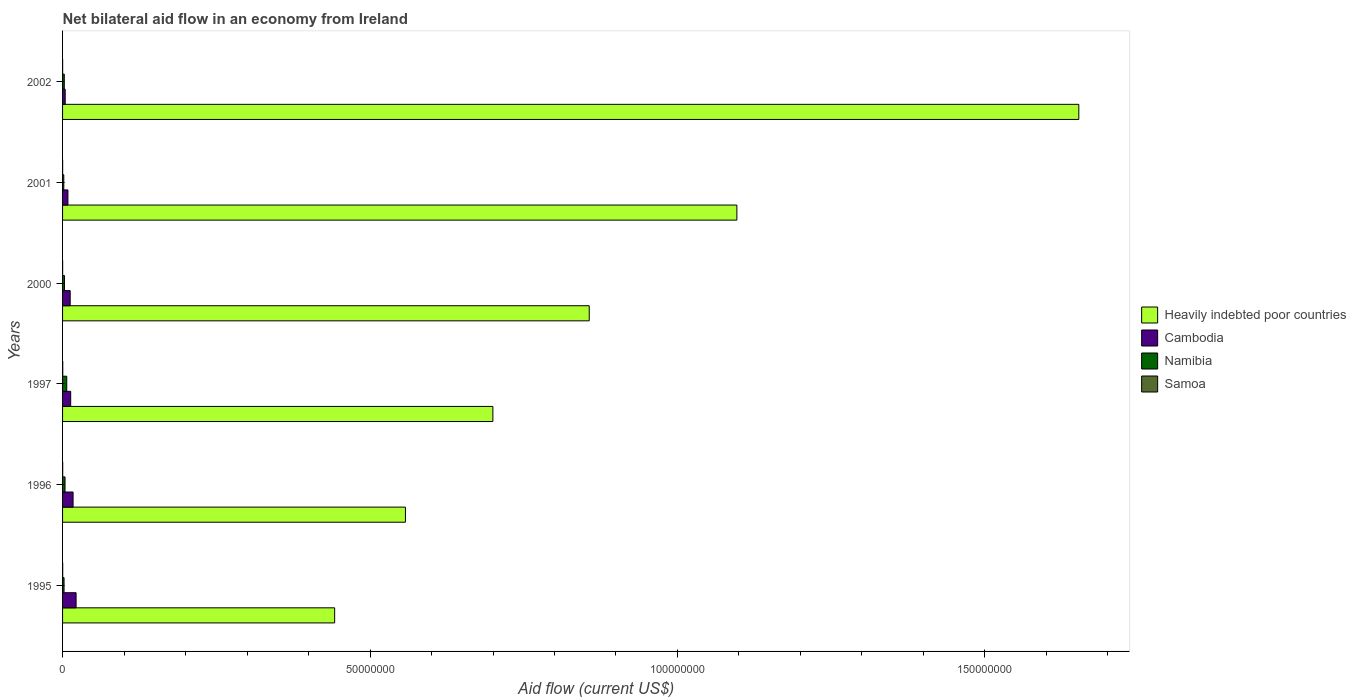Are the number of bars per tick equal to the number of legend labels?
Your answer should be very brief. Yes. How many bars are there on the 4th tick from the bottom?
Make the answer very short. 4. In how many cases, is the number of bars for a given year not equal to the number of legend labels?
Your answer should be compact. 0. What is the net bilateral aid flow in Cambodia in 1997?
Your answer should be compact. 1.32e+06. Across all years, what is the maximum net bilateral aid flow in Samoa?
Offer a terse response. 3.00e+04. Across all years, what is the minimum net bilateral aid flow in Samoa?
Your answer should be compact. 10000. What is the total net bilateral aid flow in Heavily indebted poor countries in the graph?
Provide a short and direct response. 5.31e+08. What is the difference between the net bilateral aid flow in Samoa in 1995 and that in 2000?
Your answer should be compact. 10000. What is the difference between the net bilateral aid flow in Heavily indebted poor countries in 1996 and the net bilateral aid flow in Samoa in 1995?
Provide a succinct answer. 5.57e+07. What is the average net bilateral aid flow in Namibia per year?
Provide a succinct answer. 3.52e+05. In the year 2000, what is the difference between the net bilateral aid flow in Namibia and net bilateral aid flow in Samoa?
Provide a short and direct response. 3.00e+05. In how many years, is the net bilateral aid flow in Samoa greater than 90000000 US$?
Ensure brevity in your answer.  0. What is the ratio of the net bilateral aid flow in Heavily indebted poor countries in 1995 to that in 2002?
Ensure brevity in your answer.  0.27. What is the difference between the highest and the lowest net bilateral aid flow in Heavily indebted poor countries?
Provide a succinct answer. 1.21e+08. In how many years, is the net bilateral aid flow in Cambodia greater than the average net bilateral aid flow in Cambodia taken over all years?
Your response must be concise. 3. Is the sum of the net bilateral aid flow in Namibia in 1995 and 2000 greater than the maximum net bilateral aid flow in Samoa across all years?
Ensure brevity in your answer.  Yes. Is it the case that in every year, the sum of the net bilateral aid flow in Cambodia and net bilateral aid flow in Heavily indebted poor countries is greater than the sum of net bilateral aid flow in Samoa and net bilateral aid flow in Namibia?
Make the answer very short. Yes. What does the 1st bar from the top in 2000 represents?
Your response must be concise. Samoa. What does the 2nd bar from the bottom in 1995 represents?
Give a very brief answer. Cambodia. Is it the case that in every year, the sum of the net bilateral aid flow in Samoa and net bilateral aid flow in Heavily indebted poor countries is greater than the net bilateral aid flow in Namibia?
Keep it short and to the point. Yes. How many years are there in the graph?
Offer a very short reply. 6. What is the difference between two consecutive major ticks on the X-axis?
Your answer should be compact. 5.00e+07. Are the values on the major ticks of X-axis written in scientific E-notation?
Keep it short and to the point. No. Does the graph contain any zero values?
Provide a succinct answer. No. What is the title of the graph?
Provide a succinct answer. Net bilateral aid flow in an economy from Ireland. Does "Ukraine" appear as one of the legend labels in the graph?
Give a very brief answer. No. What is the label or title of the X-axis?
Your answer should be compact. Aid flow (current US$). What is the Aid flow (current US$) of Heavily indebted poor countries in 1995?
Make the answer very short. 4.42e+07. What is the Aid flow (current US$) of Cambodia in 1995?
Keep it short and to the point. 2.20e+06. What is the Aid flow (current US$) of Namibia in 1995?
Make the answer very short. 2.40e+05. What is the Aid flow (current US$) of Samoa in 1995?
Offer a terse response. 2.00e+04. What is the Aid flow (current US$) in Heavily indebted poor countries in 1996?
Offer a terse response. 5.58e+07. What is the Aid flow (current US$) in Cambodia in 1996?
Provide a succinct answer. 1.71e+06. What is the Aid flow (current US$) of Namibia in 1996?
Your response must be concise. 4.00e+05. What is the Aid flow (current US$) in Heavily indebted poor countries in 1997?
Offer a very short reply. 7.00e+07. What is the Aid flow (current US$) of Cambodia in 1997?
Your response must be concise. 1.32e+06. What is the Aid flow (current US$) in Namibia in 1997?
Make the answer very short. 6.80e+05. What is the Aid flow (current US$) in Heavily indebted poor countries in 2000?
Offer a very short reply. 8.56e+07. What is the Aid flow (current US$) in Cambodia in 2000?
Provide a succinct answer. 1.24e+06. What is the Aid flow (current US$) in Namibia in 2000?
Give a very brief answer. 3.10e+05. What is the Aid flow (current US$) of Heavily indebted poor countries in 2001?
Provide a short and direct response. 1.10e+08. What is the Aid flow (current US$) of Cambodia in 2001?
Offer a terse response. 8.70e+05. What is the Aid flow (current US$) of Namibia in 2001?
Offer a terse response. 2.00e+05. What is the Aid flow (current US$) in Samoa in 2001?
Offer a terse response. 10000. What is the Aid flow (current US$) in Heavily indebted poor countries in 2002?
Offer a terse response. 1.65e+08. What is the Aid flow (current US$) in Cambodia in 2002?
Make the answer very short. 4.30e+05. What is the Aid flow (current US$) in Namibia in 2002?
Your answer should be compact. 2.80e+05. What is the Aid flow (current US$) of Samoa in 2002?
Make the answer very short. 10000. Across all years, what is the maximum Aid flow (current US$) of Heavily indebted poor countries?
Your answer should be very brief. 1.65e+08. Across all years, what is the maximum Aid flow (current US$) of Cambodia?
Your answer should be very brief. 2.20e+06. Across all years, what is the maximum Aid flow (current US$) of Namibia?
Provide a short and direct response. 6.80e+05. Across all years, what is the maximum Aid flow (current US$) in Samoa?
Offer a very short reply. 3.00e+04. Across all years, what is the minimum Aid flow (current US$) in Heavily indebted poor countries?
Ensure brevity in your answer.  4.42e+07. What is the total Aid flow (current US$) of Heavily indebted poor countries in the graph?
Your answer should be compact. 5.31e+08. What is the total Aid flow (current US$) in Cambodia in the graph?
Give a very brief answer. 7.77e+06. What is the total Aid flow (current US$) of Namibia in the graph?
Your answer should be compact. 2.11e+06. What is the total Aid flow (current US$) in Samoa in the graph?
Ensure brevity in your answer.  1.00e+05. What is the difference between the Aid flow (current US$) of Heavily indebted poor countries in 1995 and that in 1996?
Your response must be concise. -1.15e+07. What is the difference between the Aid flow (current US$) in Namibia in 1995 and that in 1996?
Provide a succinct answer. -1.60e+05. What is the difference between the Aid flow (current US$) of Samoa in 1995 and that in 1996?
Offer a very short reply. 0. What is the difference between the Aid flow (current US$) of Heavily indebted poor countries in 1995 and that in 1997?
Make the answer very short. -2.57e+07. What is the difference between the Aid flow (current US$) in Cambodia in 1995 and that in 1997?
Your response must be concise. 8.80e+05. What is the difference between the Aid flow (current US$) of Namibia in 1995 and that in 1997?
Keep it short and to the point. -4.40e+05. What is the difference between the Aid flow (current US$) of Heavily indebted poor countries in 1995 and that in 2000?
Your response must be concise. -4.14e+07. What is the difference between the Aid flow (current US$) of Cambodia in 1995 and that in 2000?
Give a very brief answer. 9.60e+05. What is the difference between the Aid flow (current US$) of Namibia in 1995 and that in 2000?
Your answer should be compact. -7.00e+04. What is the difference between the Aid flow (current US$) of Heavily indebted poor countries in 1995 and that in 2001?
Provide a short and direct response. -6.54e+07. What is the difference between the Aid flow (current US$) of Cambodia in 1995 and that in 2001?
Keep it short and to the point. 1.33e+06. What is the difference between the Aid flow (current US$) in Namibia in 1995 and that in 2001?
Your response must be concise. 4.00e+04. What is the difference between the Aid flow (current US$) in Heavily indebted poor countries in 1995 and that in 2002?
Ensure brevity in your answer.  -1.21e+08. What is the difference between the Aid flow (current US$) in Cambodia in 1995 and that in 2002?
Your response must be concise. 1.77e+06. What is the difference between the Aid flow (current US$) of Namibia in 1995 and that in 2002?
Offer a terse response. -4.00e+04. What is the difference between the Aid flow (current US$) in Samoa in 1995 and that in 2002?
Give a very brief answer. 10000. What is the difference between the Aid flow (current US$) in Heavily indebted poor countries in 1996 and that in 1997?
Give a very brief answer. -1.42e+07. What is the difference between the Aid flow (current US$) in Namibia in 1996 and that in 1997?
Give a very brief answer. -2.80e+05. What is the difference between the Aid flow (current US$) in Heavily indebted poor countries in 1996 and that in 2000?
Provide a succinct answer. -2.99e+07. What is the difference between the Aid flow (current US$) of Cambodia in 1996 and that in 2000?
Offer a very short reply. 4.70e+05. What is the difference between the Aid flow (current US$) of Namibia in 1996 and that in 2000?
Ensure brevity in your answer.  9.00e+04. What is the difference between the Aid flow (current US$) in Samoa in 1996 and that in 2000?
Provide a succinct answer. 10000. What is the difference between the Aid flow (current US$) in Heavily indebted poor countries in 1996 and that in 2001?
Offer a terse response. -5.39e+07. What is the difference between the Aid flow (current US$) of Cambodia in 1996 and that in 2001?
Offer a very short reply. 8.40e+05. What is the difference between the Aid flow (current US$) of Samoa in 1996 and that in 2001?
Ensure brevity in your answer.  10000. What is the difference between the Aid flow (current US$) in Heavily indebted poor countries in 1996 and that in 2002?
Keep it short and to the point. -1.10e+08. What is the difference between the Aid flow (current US$) of Cambodia in 1996 and that in 2002?
Offer a terse response. 1.28e+06. What is the difference between the Aid flow (current US$) of Namibia in 1996 and that in 2002?
Ensure brevity in your answer.  1.20e+05. What is the difference between the Aid flow (current US$) of Heavily indebted poor countries in 1997 and that in 2000?
Provide a succinct answer. -1.57e+07. What is the difference between the Aid flow (current US$) of Cambodia in 1997 and that in 2000?
Your answer should be compact. 8.00e+04. What is the difference between the Aid flow (current US$) in Samoa in 1997 and that in 2000?
Ensure brevity in your answer.  2.00e+04. What is the difference between the Aid flow (current US$) in Heavily indebted poor countries in 1997 and that in 2001?
Provide a succinct answer. -3.97e+07. What is the difference between the Aid flow (current US$) of Cambodia in 1997 and that in 2001?
Your answer should be very brief. 4.50e+05. What is the difference between the Aid flow (current US$) in Samoa in 1997 and that in 2001?
Offer a terse response. 2.00e+04. What is the difference between the Aid flow (current US$) of Heavily indebted poor countries in 1997 and that in 2002?
Your response must be concise. -9.53e+07. What is the difference between the Aid flow (current US$) of Cambodia in 1997 and that in 2002?
Ensure brevity in your answer.  8.90e+05. What is the difference between the Aid flow (current US$) in Namibia in 1997 and that in 2002?
Ensure brevity in your answer.  4.00e+05. What is the difference between the Aid flow (current US$) of Samoa in 1997 and that in 2002?
Ensure brevity in your answer.  2.00e+04. What is the difference between the Aid flow (current US$) of Heavily indebted poor countries in 2000 and that in 2001?
Keep it short and to the point. -2.40e+07. What is the difference between the Aid flow (current US$) in Namibia in 2000 and that in 2001?
Your answer should be compact. 1.10e+05. What is the difference between the Aid flow (current US$) of Samoa in 2000 and that in 2001?
Offer a terse response. 0. What is the difference between the Aid flow (current US$) in Heavily indebted poor countries in 2000 and that in 2002?
Your answer should be very brief. -7.96e+07. What is the difference between the Aid flow (current US$) in Cambodia in 2000 and that in 2002?
Provide a succinct answer. 8.10e+05. What is the difference between the Aid flow (current US$) in Heavily indebted poor countries in 2001 and that in 2002?
Your answer should be compact. -5.56e+07. What is the difference between the Aid flow (current US$) of Cambodia in 2001 and that in 2002?
Ensure brevity in your answer.  4.40e+05. What is the difference between the Aid flow (current US$) of Samoa in 2001 and that in 2002?
Give a very brief answer. 0. What is the difference between the Aid flow (current US$) in Heavily indebted poor countries in 1995 and the Aid flow (current US$) in Cambodia in 1996?
Offer a terse response. 4.25e+07. What is the difference between the Aid flow (current US$) in Heavily indebted poor countries in 1995 and the Aid flow (current US$) in Namibia in 1996?
Ensure brevity in your answer.  4.38e+07. What is the difference between the Aid flow (current US$) of Heavily indebted poor countries in 1995 and the Aid flow (current US$) of Samoa in 1996?
Make the answer very short. 4.42e+07. What is the difference between the Aid flow (current US$) of Cambodia in 1995 and the Aid flow (current US$) of Namibia in 1996?
Ensure brevity in your answer.  1.80e+06. What is the difference between the Aid flow (current US$) in Cambodia in 1995 and the Aid flow (current US$) in Samoa in 1996?
Provide a succinct answer. 2.18e+06. What is the difference between the Aid flow (current US$) of Namibia in 1995 and the Aid flow (current US$) of Samoa in 1996?
Offer a terse response. 2.20e+05. What is the difference between the Aid flow (current US$) in Heavily indebted poor countries in 1995 and the Aid flow (current US$) in Cambodia in 1997?
Make the answer very short. 4.29e+07. What is the difference between the Aid flow (current US$) of Heavily indebted poor countries in 1995 and the Aid flow (current US$) of Namibia in 1997?
Keep it short and to the point. 4.36e+07. What is the difference between the Aid flow (current US$) of Heavily indebted poor countries in 1995 and the Aid flow (current US$) of Samoa in 1997?
Your answer should be very brief. 4.42e+07. What is the difference between the Aid flow (current US$) in Cambodia in 1995 and the Aid flow (current US$) in Namibia in 1997?
Offer a terse response. 1.52e+06. What is the difference between the Aid flow (current US$) in Cambodia in 1995 and the Aid flow (current US$) in Samoa in 1997?
Give a very brief answer. 2.17e+06. What is the difference between the Aid flow (current US$) in Namibia in 1995 and the Aid flow (current US$) in Samoa in 1997?
Keep it short and to the point. 2.10e+05. What is the difference between the Aid flow (current US$) of Heavily indebted poor countries in 1995 and the Aid flow (current US$) of Cambodia in 2000?
Give a very brief answer. 4.30e+07. What is the difference between the Aid flow (current US$) in Heavily indebted poor countries in 1995 and the Aid flow (current US$) in Namibia in 2000?
Offer a very short reply. 4.39e+07. What is the difference between the Aid flow (current US$) of Heavily indebted poor countries in 1995 and the Aid flow (current US$) of Samoa in 2000?
Offer a terse response. 4.42e+07. What is the difference between the Aid flow (current US$) in Cambodia in 1995 and the Aid flow (current US$) in Namibia in 2000?
Make the answer very short. 1.89e+06. What is the difference between the Aid flow (current US$) in Cambodia in 1995 and the Aid flow (current US$) in Samoa in 2000?
Provide a succinct answer. 2.19e+06. What is the difference between the Aid flow (current US$) in Namibia in 1995 and the Aid flow (current US$) in Samoa in 2000?
Offer a very short reply. 2.30e+05. What is the difference between the Aid flow (current US$) in Heavily indebted poor countries in 1995 and the Aid flow (current US$) in Cambodia in 2001?
Provide a short and direct response. 4.34e+07. What is the difference between the Aid flow (current US$) in Heavily indebted poor countries in 1995 and the Aid flow (current US$) in Namibia in 2001?
Your response must be concise. 4.40e+07. What is the difference between the Aid flow (current US$) in Heavily indebted poor countries in 1995 and the Aid flow (current US$) in Samoa in 2001?
Your response must be concise. 4.42e+07. What is the difference between the Aid flow (current US$) of Cambodia in 1995 and the Aid flow (current US$) of Namibia in 2001?
Provide a succinct answer. 2.00e+06. What is the difference between the Aid flow (current US$) of Cambodia in 1995 and the Aid flow (current US$) of Samoa in 2001?
Your answer should be very brief. 2.19e+06. What is the difference between the Aid flow (current US$) in Heavily indebted poor countries in 1995 and the Aid flow (current US$) in Cambodia in 2002?
Offer a very short reply. 4.38e+07. What is the difference between the Aid flow (current US$) in Heavily indebted poor countries in 1995 and the Aid flow (current US$) in Namibia in 2002?
Your answer should be compact. 4.40e+07. What is the difference between the Aid flow (current US$) in Heavily indebted poor countries in 1995 and the Aid flow (current US$) in Samoa in 2002?
Provide a short and direct response. 4.42e+07. What is the difference between the Aid flow (current US$) of Cambodia in 1995 and the Aid flow (current US$) of Namibia in 2002?
Your answer should be compact. 1.92e+06. What is the difference between the Aid flow (current US$) in Cambodia in 1995 and the Aid flow (current US$) in Samoa in 2002?
Offer a terse response. 2.19e+06. What is the difference between the Aid flow (current US$) in Heavily indebted poor countries in 1996 and the Aid flow (current US$) in Cambodia in 1997?
Make the answer very short. 5.44e+07. What is the difference between the Aid flow (current US$) of Heavily indebted poor countries in 1996 and the Aid flow (current US$) of Namibia in 1997?
Offer a very short reply. 5.51e+07. What is the difference between the Aid flow (current US$) in Heavily indebted poor countries in 1996 and the Aid flow (current US$) in Samoa in 1997?
Ensure brevity in your answer.  5.57e+07. What is the difference between the Aid flow (current US$) in Cambodia in 1996 and the Aid flow (current US$) in Namibia in 1997?
Your answer should be very brief. 1.03e+06. What is the difference between the Aid flow (current US$) of Cambodia in 1996 and the Aid flow (current US$) of Samoa in 1997?
Make the answer very short. 1.68e+06. What is the difference between the Aid flow (current US$) of Namibia in 1996 and the Aid flow (current US$) of Samoa in 1997?
Your answer should be very brief. 3.70e+05. What is the difference between the Aid flow (current US$) of Heavily indebted poor countries in 1996 and the Aid flow (current US$) of Cambodia in 2000?
Offer a very short reply. 5.45e+07. What is the difference between the Aid flow (current US$) in Heavily indebted poor countries in 1996 and the Aid flow (current US$) in Namibia in 2000?
Give a very brief answer. 5.54e+07. What is the difference between the Aid flow (current US$) of Heavily indebted poor countries in 1996 and the Aid flow (current US$) of Samoa in 2000?
Make the answer very short. 5.58e+07. What is the difference between the Aid flow (current US$) of Cambodia in 1996 and the Aid flow (current US$) of Namibia in 2000?
Provide a succinct answer. 1.40e+06. What is the difference between the Aid flow (current US$) in Cambodia in 1996 and the Aid flow (current US$) in Samoa in 2000?
Give a very brief answer. 1.70e+06. What is the difference between the Aid flow (current US$) of Heavily indebted poor countries in 1996 and the Aid flow (current US$) of Cambodia in 2001?
Make the answer very short. 5.49e+07. What is the difference between the Aid flow (current US$) in Heavily indebted poor countries in 1996 and the Aid flow (current US$) in Namibia in 2001?
Make the answer very short. 5.56e+07. What is the difference between the Aid flow (current US$) in Heavily indebted poor countries in 1996 and the Aid flow (current US$) in Samoa in 2001?
Ensure brevity in your answer.  5.58e+07. What is the difference between the Aid flow (current US$) in Cambodia in 1996 and the Aid flow (current US$) in Namibia in 2001?
Offer a very short reply. 1.51e+06. What is the difference between the Aid flow (current US$) in Cambodia in 1996 and the Aid flow (current US$) in Samoa in 2001?
Your answer should be very brief. 1.70e+06. What is the difference between the Aid flow (current US$) of Namibia in 1996 and the Aid flow (current US$) of Samoa in 2001?
Your answer should be compact. 3.90e+05. What is the difference between the Aid flow (current US$) in Heavily indebted poor countries in 1996 and the Aid flow (current US$) in Cambodia in 2002?
Provide a succinct answer. 5.53e+07. What is the difference between the Aid flow (current US$) in Heavily indebted poor countries in 1996 and the Aid flow (current US$) in Namibia in 2002?
Your response must be concise. 5.55e+07. What is the difference between the Aid flow (current US$) in Heavily indebted poor countries in 1996 and the Aid flow (current US$) in Samoa in 2002?
Provide a succinct answer. 5.58e+07. What is the difference between the Aid flow (current US$) of Cambodia in 1996 and the Aid flow (current US$) of Namibia in 2002?
Offer a very short reply. 1.43e+06. What is the difference between the Aid flow (current US$) of Cambodia in 1996 and the Aid flow (current US$) of Samoa in 2002?
Ensure brevity in your answer.  1.70e+06. What is the difference between the Aid flow (current US$) in Namibia in 1996 and the Aid flow (current US$) in Samoa in 2002?
Provide a succinct answer. 3.90e+05. What is the difference between the Aid flow (current US$) in Heavily indebted poor countries in 1997 and the Aid flow (current US$) in Cambodia in 2000?
Make the answer very short. 6.87e+07. What is the difference between the Aid flow (current US$) in Heavily indebted poor countries in 1997 and the Aid flow (current US$) in Namibia in 2000?
Your answer should be compact. 6.97e+07. What is the difference between the Aid flow (current US$) in Heavily indebted poor countries in 1997 and the Aid flow (current US$) in Samoa in 2000?
Offer a very short reply. 7.00e+07. What is the difference between the Aid flow (current US$) in Cambodia in 1997 and the Aid flow (current US$) in Namibia in 2000?
Your response must be concise. 1.01e+06. What is the difference between the Aid flow (current US$) of Cambodia in 1997 and the Aid flow (current US$) of Samoa in 2000?
Provide a succinct answer. 1.31e+06. What is the difference between the Aid flow (current US$) in Namibia in 1997 and the Aid flow (current US$) in Samoa in 2000?
Your answer should be compact. 6.70e+05. What is the difference between the Aid flow (current US$) of Heavily indebted poor countries in 1997 and the Aid flow (current US$) of Cambodia in 2001?
Give a very brief answer. 6.91e+07. What is the difference between the Aid flow (current US$) in Heavily indebted poor countries in 1997 and the Aid flow (current US$) in Namibia in 2001?
Your answer should be very brief. 6.98e+07. What is the difference between the Aid flow (current US$) in Heavily indebted poor countries in 1997 and the Aid flow (current US$) in Samoa in 2001?
Ensure brevity in your answer.  7.00e+07. What is the difference between the Aid flow (current US$) in Cambodia in 1997 and the Aid flow (current US$) in Namibia in 2001?
Keep it short and to the point. 1.12e+06. What is the difference between the Aid flow (current US$) of Cambodia in 1997 and the Aid flow (current US$) of Samoa in 2001?
Provide a short and direct response. 1.31e+06. What is the difference between the Aid flow (current US$) in Namibia in 1997 and the Aid flow (current US$) in Samoa in 2001?
Keep it short and to the point. 6.70e+05. What is the difference between the Aid flow (current US$) of Heavily indebted poor countries in 1997 and the Aid flow (current US$) of Cambodia in 2002?
Give a very brief answer. 6.96e+07. What is the difference between the Aid flow (current US$) of Heavily indebted poor countries in 1997 and the Aid flow (current US$) of Namibia in 2002?
Ensure brevity in your answer.  6.97e+07. What is the difference between the Aid flow (current US$) in Heavily indebted poor countries in 1997 and the Aid flow (current US$) in Samoa in 2002?
Make the answer very short. 7.00e+07. What is the difference between the Aid flow (current US$) in Cambodia in 1997 and the Aid flow (current US$) in Namibia in 2002?
Make the answer very short. 1.04e+06. What is the difference between the Aid flow (current US$) of Cambodia in 1997 and the Aid flow (current US$) of Samoa in 2002?
Keep it short and to the point. 1.31e+06. What is the difference between the Aid flow (current US$) of Namibia in 1997 and the Aid flow (current US$) of Samoa in 2002?
Your response must be concise. 6.70e+05. What is the difference between the Aid flow (current US$) of Heavily indebted poor countries in 2000 and the Aid flow (current US$) of Cambodia in 2001?
Offer a terse response. 8.48e+07. What is the difference between the Aid flow (current US$) in Heavily indebted poor countries in 2000 and the Aid flow (current US$) in Namibia in 2001?
Offer a terse response. 8.54e+07. What is the difference between the Aid flow (current US$) of Heavily indebted poor countries in 2000 and the Aid flow (current US$) of Samoa in 2001?
Provide a short and direct response. 8.56e+07. What is the difference between the Aid flow (current US$) of Cambodia in 2000 and the Aid flow (current US$) of Namibia in 2001?
Keep it short and to the point. 1.04e+06. What is the difference between the Aid flow (current US$) in Cambodia in 2000 and the Aid flow (current US$) in Samoa in 2001?
Make the answer very short. 1.23e+06. What is the difference between the Aid flow (current US$) of Namibia in 2000 and the Aid flow (current US$) of Samoa in 2001?
Offer a very short reply. 3.00e+05. What is the difference between the Aid flow (current US$) of Heavily indebted poor countries in 2000 and the Aid flow (current US$) of Cambodia in 2002?
Keep it short and to the point. 8.52e+07. What is the difference between the Aid flow (current US$) of Heavily indebted poor countries in 2000 and the Aid flow (current US$) of Namibia in 2002?
Provide a short and direct response. 8.54e+07. What is the difference between the Aid flow (current US$) of Heavily indebted poor countries in 2000 and the Aid flow (current US$) of Samoa in 2002?
Provide a succinct answer. 8.56e+07. What is the difference between the Aid flow (current US$) in Cambodia in 2000 and the Aid flow (current US$) in Namibia in 2002?
Keep it short and to the point. 9.60e+05. What is the difference between the Aid flow (current US$) in Cambodia in 2000 and the Aid flow (current US$) in Samoa in 2002?
Ensure brevity in your answer.  1.23e+06. What is the difference between the Aid flow (current US$) in Heavily indebted poor countries in 2001 and the Aid flow (current US$) in Cambodia in 2002?
Your answer should be very brief. 1.09e+08. What is the difference between the Aid flow (current US$) in Heavily indebted poor countries in 2001 and the Aid flow (current US$) in Namibia in 2002?
Your answer should be compact. 1.09e+08. What is the difference between the Aid flow (current US$) in Heavily indebted poor countries in 2001 and the Aid flow (current US$) in Samoa in 2002?
Provide a succinct answer. 1.10e+08. What is the difference between the Aid flow (current US$) of Cambodia in 2001 and the Aid flow (current US$) of Namibia in 2002?
Provide a short and direct response. 5.90e+05. What is the difference between the Aid flow (current US$) in Cambodia in 2001 and the Aid flow (current US$) in Samoa in 2002?
Your response must be concise. 8.60e+05. What is the difference between the Aid flow (current US$) in Namibia in 2001 and the Aid flow (current US$) in Samoa in 2002?
Offer a terse response. 1.90e+05. What is the average Aid flow (current US$) of Heavily indebted poor countries per year?
Make the answer very short. 8.84e+07. What is the average Aid flow (current US$) in Cambodia per year?
Give a very brief answer. 1.30e+06. What is the average Aid flow (current US$) in Namibia per year?
Offer a terse response. 3.52e+05. What is the average Aid flow (current US$) of Samoa per year?
Make the answer very short. 1.67e+04. In the year 1995, what is the difference between the Aid flow (current US$) in Heavily indebted poor countries and Aid flow (current US$) in Cambodia?
Offer a terse response. 4.20e+07. In the year 1995, what is the difference between the Aid flow (current US$) of Heavily indebted poor countries and Aid flow (current US$) of Namibia?
Make the answer very short. 4.40e+07. In the year 1995, what is the difference between the Aid flow (current US$) of Heavily indebted poor countries and Aid flow (current US$) of Samoa?
Your answer should be very brief. 4.42e+07. In the year 1995, what is the difference between the Aid flow (current US$) in Cambodia and Aid flow (current US$) in Namibia?
Provide a short and direct response. 1.96e+06. In the year 1995, what is the difference between the Aid flow (current US$) of Cambodia and Aid flow (current US$) of Samoa?
Provide a succinct answer. 2.18e+06. In the year 1996, what is the difference between the Aid flow (current US$) in Heavily indebted poor countries and Aid flow (current US$) in Cambodia?
Your response must be concise. 5.40e+07. In the year 1996, what is the difference between the Aid flow (current US$) of Heavily indebted poor countries and Aid flow (current US$) of Namibia?
Your answer should be compact. 5.54e+07. In the year 1996, what is the difference between the Aid flow (current US$) in Heavily indebted poor countries and Aid flow (current US$) in Samoa?
Offer a very short reply. 5.57e+07. In the year 1996, what is the difference between the Aid flow (current US$) in Cambodia and Aid flow (current US$) in Namibia?
Provide a short and direct response. 1.31e+06. In the year 1996, what is the difference between the Aid flow (current US$) in Cambodia and Aid flow (current US$) in Samoa?
Your answer should be very brief. 1.69e+06. In the year 1997, what is the difference between the Aid flow (current US$) of Heavily indebted poor countries and Aid flow (current US$) of Cambodia?
Keep it short and to the point. 6.87e+07. In the year 1997, what is the difference between the Aid flow (current US$) in Heavily indebted poor countries and Aid flow (current US$) in Namibia?
Ensure brevity in your answer.  6.93e+07. In the year 1997, what is the difference between the Aid flow (current US$) in Heavily indebted poor countries and Aid flow (current US$) in Samoa?
Ensure brevity in your answer.  7.00e+07. In the year 1997, what is the difference between the Aid flow (current US$) in Cambodia and Aid flow (current US$) in Namibia?
Make the answer very short. 6.40e+05. In the year 1997, what is the difference between the Aid flow (current US$) of Cambodia and Aid flow (current US$) of Samoa?
Your answer should be very brief. 1.29e+06. In the year 1997, what is the difference between the Aid flow (current US$) in Namibia and Aid flow (current US$) in Samoa?
Ensure brevity in your answer.  6.50e+05. In the year 2000, what is the difference between the Aid flow (current US$) of Heavily indebted poor countries and Aid flow (current US$) of Cambodia?
Provide a short and direct response. 8.44e+07. In the year 2000, what is the difference between the Aid flow (current US$) of Heavily indebted poor countries and Aid flow (current US$) of Namibia?
Offer a terse response. 8.53e+07. In the year 2000, what is the difference between the Aid flow (current US$) of Heavily indebted poor countries and Aid flow (current US$) of Samoa?
Make the answer very short. 8.56e+07. In the year 2000, what is the difference between the Aid flow (current US$) in Cambodia and Aid flow (current US$) in Namibia?
Offer a terse response. 9.30e+05. In the year 2000, what is the difference between the Aid flow (current US$) in Cambodia and Aid flow (current US$) in Samoa?
Provide a short and direct response. 1.23e+06. In the year 2000, what is the difference between the Aid flow (current US$) of Namibia and Aid flow (current US$) of Samoa?
Provide a succinct answer. 3.00e+05. In the year 2001, what is the difference between the Aid flow (current US$) of Heavily indebted poor countries and Aid flow (current US$) of Cambodia?
Keep it short and to the point. 1.09e+08. In the year 2001, what is the difference between the Aid flow (current US$) of Heavily indebted poor countries and Aid flow (current US$) of Namibia?
Make the answer very short. 1.09e+08. In the year 2001, what is the difference between the Aid flow (current US$) of Heavily indebted poor countries and Aid flow (current US$) of Samoa?
Your answer should be compact. 1.10e+08. In the year 2001, what is the difference between the Aid flow (current US$) in Cambodia and Aid flow (current US$) in Namibia?
Your answer should be very brief. 6.70e+05. In the year 2001, what is the difference between the Aid flow (current US$) in Cambodia and Aid flow (current US$) in Samoa?
Provide a short and direct response. 8.60e+05. In the year 2002, what is the difference between the Aid flow (current US$) of Heavily indebted poor countries and Aid flow (current US$) of Cambodia?
Your answer should be compact. 1.65e+08. In the year 2002, what is the difference between the Aid flow (current US$) of Heavily indebted poor countries and Aid flow (current US$) of Namibia?
Your answer should be compact. 1.65e+08. In the year 2002, what is the difference between the Aid flow (current US$) in Heavily indebted poor countries and Aid flow (current US$) in Samoa?
Offer a very short reply. 1.65e+08. What is the ratio of the Aid flow (current US$) of Heavily indebted poor countries in 1995 to that in 1996?
Offer a terse response. 0.79. What is the ratio of the Aid flow (current US$) in Cambodia in 1995 to that in 1996?
Your response must be concise. 1.29. What is the ratio of the Aid flow (current US$) of Samoa in 1995 to that in 1996?
Make the answer very short. 1. What is the ratio of the Aid flow (current US$) in Heavily indebted poor countries in 1995 to that in 1997?
Make the answer very short. 0.63. What is the ratio of the Aid flow (current US$) in Namibia in 1995 to that in 1997?
Give a very brief answer. 0.35. What is the ratio of the Aid flow (current US$) in Samoa in 1995 to that in 1997?
Provide a succinct answer. 0.67. What is the ratio of the Aid flow (current US$) in Heavily indebted poor countries in 1995 to that in 2000?
Provide a succinct answer. 0.52. What is the ratio of the Aid flow (current US$) of Cambodia in 1995 to that in 2000?
Your response must be concise. 1.77. What is the ratio of the Aid flow (current US$) of Namibia in 1995 to that in 2000?
Ensure brevity in your answer.  0.77. What is the ratio of the Aid flow (current US$) in Samoa in 1995 to that in 2000?
Offer a very short reply. 2. What is the ratio of the Aid flow (current US$) of Heavily indebted poor countries in 1995 to that in 2001?
Provide a succinct answer. 0.4. What is the ratio of the Aid flow (current US$) of Cambodia in 1995 to that in 2001?
Offer a very short reply. 2.53. What is the ratio of the Aid flow (current US$) in Namibia in 1995 to that in 2001?
Provide a short and direct response. 1.2. What is the ratio of the Aid flow (current US$) in Samoa in 1995 to that in 2001?
Your answer should be very brief. 2. What is the ratio of the Aid flow (current US$) of Heavily indebted poor countries in 1995 to that in 2002?
Offer a very short reply. 0.27. What is the ratio of the Aid flow (current US$) in Cambodia in 1995 to that in 2002?
Your response must be concise. 5.12. What is the ratio of the Aid flow (current US$) in Namibia in 1995 to that in 2002?
Provide a succinct answer. 0.86. What is the ratio of the Aid flow (current US$) in Heavily indebted poor countries in 1996 to that in 1997?
Make the answer very short. 0.8. What is the ratio of the Aid flow (current US$) of Cambodia in 1996 to that in 1997?
Keep it short and to the point. 1.3. What is the ratio of the Aid flow (current US$) of Namibia in 1996 to that in 1997?
Ensure brevity in your answer.  0.59. What is the ratio of the Aid flow (current US$) in Samoa in 1996 to that in 1997?
Offer a terse response. 0.67. What is the ratio of the Aid flow (current US$) in Heavily indebted poor countries in 1996 to that in 2000?
Your response must be concise. 0.65. What is the ratio of the Aid flow (current US$) in Cambodia in 1996 to that in 2000?
Offer a terse response. 1.38. What is the ratio of the Aid flow (current US$) of Namibia in 1996 to that in 2000?
Your response must be concise. 1.29. What is the ratio of the Aid flow (current US$) of Heavily indebted poor countries in 1996 to that in 2001?
Your answer should be very brief. 0.51. What is the ratio of the Aid flow (current US$) in Cambodia in 1996 to that in 2001?
Give a very brief answer. 1.97. What is the ratio of the Aid flow (current US$) of Heavily indebted poor countries in 1996 to that in 2002?
Provide a succinct answer. 0.34. What is the ratio of the Aid flow (current US$) of Cambodia in 1996 to that in 2002?
Offer a very short reply. 3.98. What is the ratio of the Aid flow (current US$) of Namibia in 1996 to that in 2002?
Make the answer very short. 1.43. What is the ratio of the Aid flow (current US$) in Samoa in 1996 to that in 2002?
Offer a very short reply. 2. What is the ratio of the Aid flow (current US$) of Heavily indebted poor countries in 1997 to that in 2000?
Offer a terse response. 0.82. What is the ratio of the Aid flow (current US$) in Cambodia in 1997 to that in 2000?
Give a very brief answer. 1.06. What is the ratio of the Aid flow (current US$) in Namibia in 1997 to that in 2000?
Your answer should be very brief. 2.19. What is the ratio of the Aid flow (current US$) in Heavily indebted poor countries in 1997 to that in 2001?
Make the answer very short. 0.64. What is the ratio of the Aid flow (current US$) of Cambodia in 1997 to that in 2001?
Ensure brevity in your answer.  1.52. What is the ratio of the Aid flow (current US$) of Heavily indebted poor countries in 1997 to that in 2002?
Make the answer very short. 0.42. What is the ratio of the Aid flow (current US$) of Cambodia in 1997 to that in 2002?
Your answer should be compact. 3.07. What is the ratio of the Aid flow (current US$) of Namibia in 1997 to that in 2002?
Give a very brief answer. 2.43. What is the ratio of the Aid flow (current US$) of Heavily indebted poor countries in 2000 to that in 2001?
Offer a very short reply. 0.78. What is the ratio of the Aid flow (current US$) in Cambodia in 2000 to that in 2001?
Your answer should be compact. 1.43. What is the ratio of the Aid flow (current US$) of Namibia in 2000 to that in 2001?
Offer a terse response. 1.55. What is the ratio of the Aid flow (current US$) of Samoa in 2000 to that in 2001?
Your answer should be very brief. 1. What is the ratio of the Aid flow (current US$) of Heavily indebted poor countries in 2000 to that in 2002?
Your answer should be compact. 0.52. What is the ratio of the Aid flow (current US$) of Cambodia in 2000 to that in 2002?
Keep it short and to the point. 2.88. What is the ratio of the Aid flow (current US$) of Namibia in 2000 to that in 2002?
Keep it short and to the point. 1.11. What is the ratio of the Aid flow (current US$) of Samoa in 2000 to that in 2002?
Your answer should be very brief. 1. What is the ratio of the Aid flow (current US$) in Heavily indebted poor countries in 2001 to that in 2002?
Offer a very short reply. 0.66. What is the ratio of the Aid flow (current US$) in Cambodia in 2001 to that in 2002?
Make the answer very short. 2.02. What is the ratio of the Aid flow (current US$) of Samoa in 2001 to that in 2002?
Provide a succinct answer. 1. What is the difference between the highest and the second highest Aid flow (current US$) of Heavily indebted poor countries?
Your answer should be compact. 5.56e+07. What is the difference between the highest and the second highest Aid flow (current US$) of Cambodia?
Offer a very short reply. 4.90e+05. What is the difference between the highest and the second highest Aid flow (current US$) in Namibia?
Ensure brevity in your answer.  2.80e+05. What is the difference between the highest and the lowest Aid flow (current US$) in Heavily indebted poor countries?
Make the answer very short. 1.21e+08. What is the difference between the highest and the lowest Aid flow (current US$) of Cambodia?
Ensure brevity in your answer.  1.77e+06. What is the difference between the highest and the lowest Aid flow (current US$) in Samoa?
Give a very brief answer. 2.00e+04. 